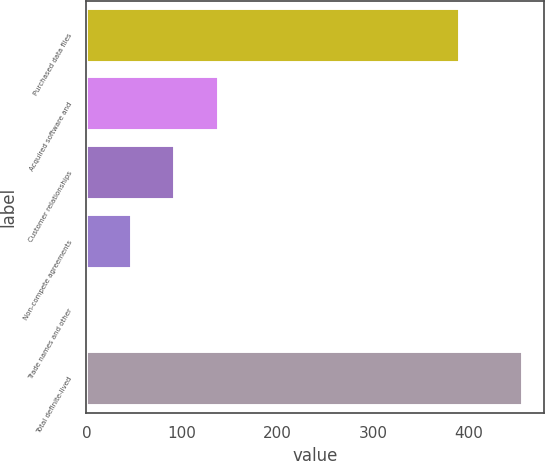Convert chart. <chart><loc_0><loc_0><loc_500><loc_500><bar_chart><fcel>Purchased data files<fcel>Acquired software and<fcel>Customer relationships<fcel>Non-compete agreements<fcel>Trade names and other<fcel>Total definite-lived<nl><fcel>390.8<fcel>138.29<fcel>92.86<fcel>47.43<fcel>2<fcel>456.3<nl></chart> 